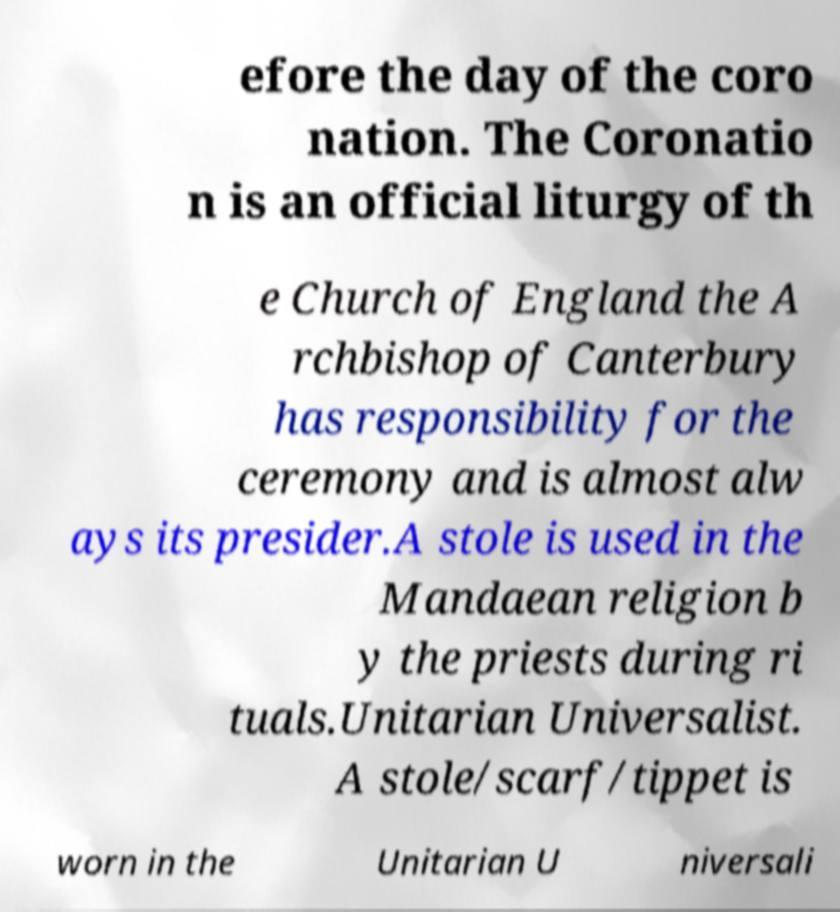Can you read and provide the text displayed in the image?This photo seems to have some interesting text. Can you extract and type it out for me? efore the day of the coro nation. The Coronatio n is an official liturgy of th e Church of England the A rchbishop of Canterbury has responsibility for the ceremony and is almost alw ays its presider.A stole is used in the Mandaean religion b y the priests during ri tuals.Unitarian Universalist. A stole/scarf/tippet is worn in the Unitarian U niversali 